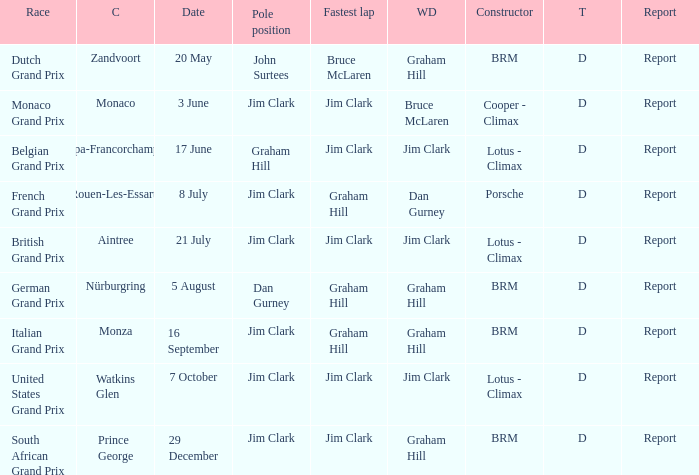What is the date of the circuit of Monaco? 3 June. 